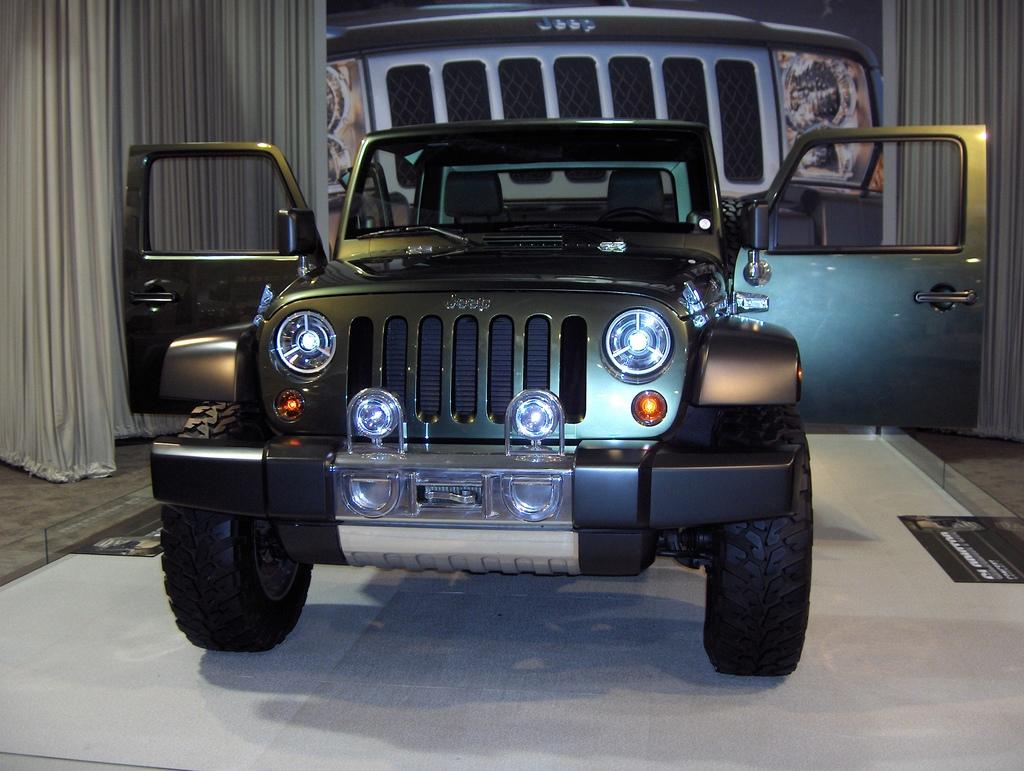What is the main subject of the picture? The main subject of the picture is a car. What features can be seen on the car? The car has a windshield, doors, a mirror, and headlights. Is there any additional information about the car in the picture? Yes, there is a banner of the car in the backdrop. Are there any other objects or elements in the picture? Yes, there is a curtain in the picture. What type of calculator can be seen on the car's dashboard in the image? There is no calculator visible on the car's dashboard in the image. Are there any stockings hanging from the car's mirror in the image? There are no stockings present in the image. 